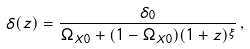Convert formula to latex. <formula><loc_0><loc_0><loc_500><loc_500>\delta ( z ) = \frac { \delta _ { 0 } } { \Omega _ { X 0 } + ( 1 - \Omega _ { X 0 } ) ( 1 + z ) ^ { \xi } } \, ,</formula> 